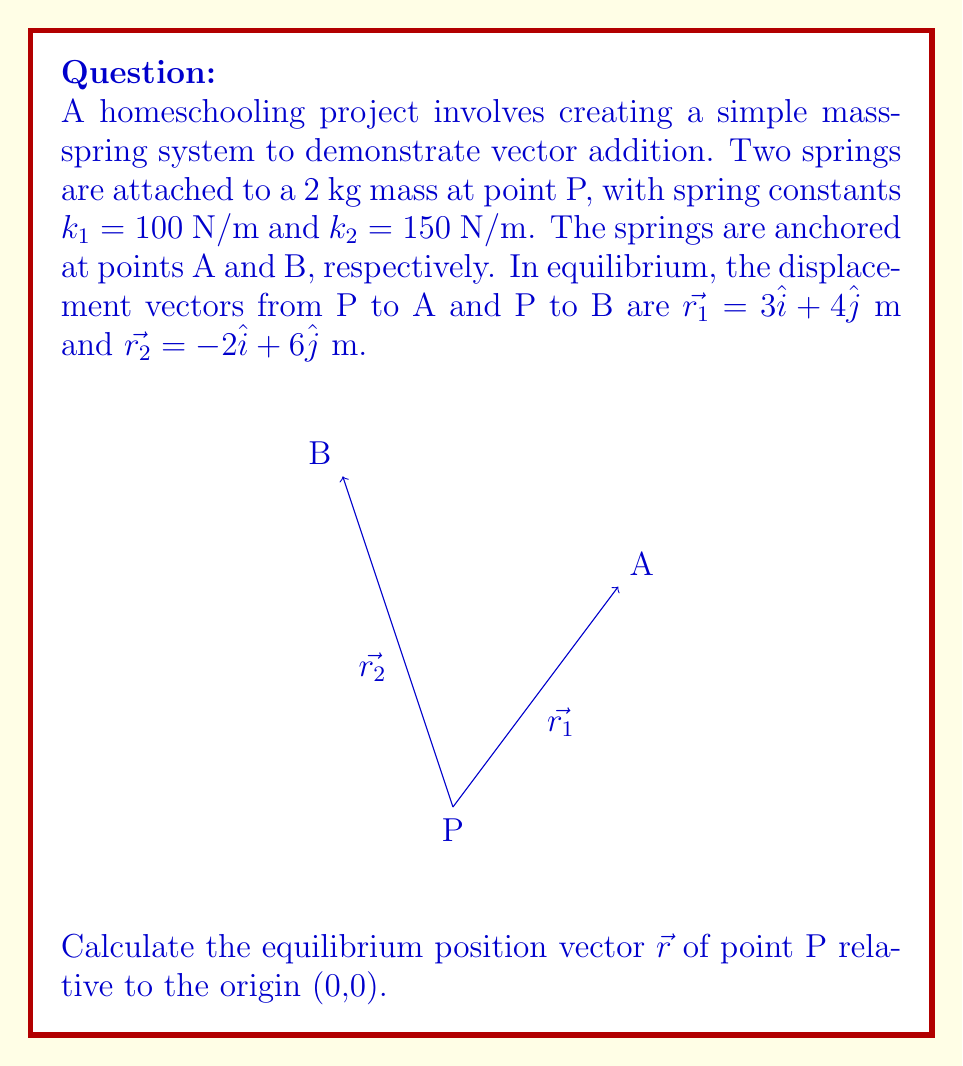Provide a solution to this math problem. Let's solve this step-by-step:

1) In equilibrium, the net force on the mass is zero. This means the sum of the spring forces must equal zero:

   $$\vec{F_1} + \vec{F_2} = \vec{0}$$

2) The force of a spring is given by Hooke's law: $\vec{F} = -k\vec{r}$. For each spring:

   $$\vec{F_1} = -k_1\vec{r_1} = -(100)(-3\hat{i} - 4\hat{j}) = 300\hat{i} + 400\hat{j}$$
   $$\vec{F_2} = -k_2\vec{r_2} = -(150)(2\hat{i} - 6\hat{j}) = -300\hat{i} + 900\hat{j}$$

3) Substituting these into the equilibrium equation:

   $$(300\hat{i} + 400\hat{j}) + (-300\hat{i} + 900\hat{j}) = \vec{0}$$

4) Simplifying:

   $$0\hat{i} + 1300\hat{j} = \vec{0}$$

5) This equation tells us that the y-component of the equilibrium position must be such that the net force in the y-direction is 1300 N upward.

6) The net force in the y-direction is:

   $$F_y = -k_1y - k_2y = -(100 + 150)y = -250y = 1300$$

7) Solving for y:

   $$y = -\frac{1300}{250} = -5.2\text{ m}$$

8) Since there's no net force in the x-direction, the x-component of the equilibrium position is 0.

Therefore, the equilibrium position vector is:

$$\vec{r} = 0\hat{i} - 5.2\hat{j}$$
Answer: $\vec{r} = -5.2\hat{j}$ m 